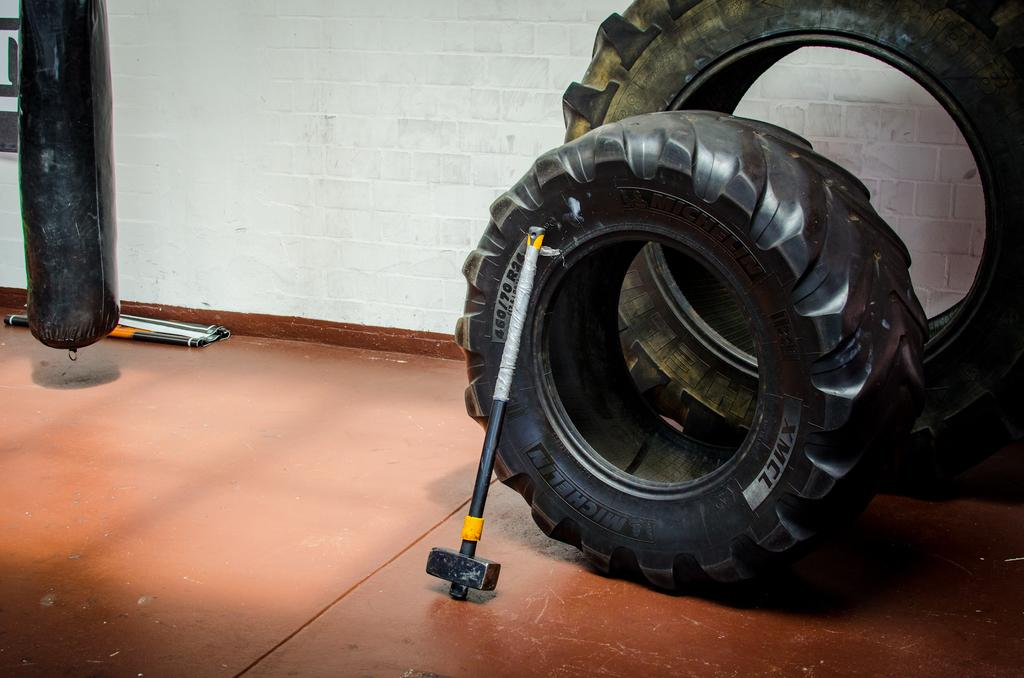What tool is visible in the image? There is a hammer in the image. What type of objects are also present in the image? There are tires in the image. Where are the hammer and tires located? The hammer and tires are on the wall. What can be seen in the background of the image? There is a wall in the background of the image. What type of quiver is hanging next to the hammer and tires in the image? There is no quiver present in the image; it only features a hammer and tires on the wall. 